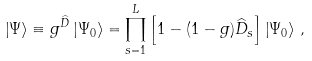<formula> <loc_0><loc_0><loc_500><loc_500>\left | \Psi \right \rangle \equiv g ^ { \widehat { D } } \left | \Psi _ { 0 } \right \rangle = \prod _ { s = 1 } ^ { L } \left [ 1 - ( 1 - g ) \widehat { D } _ { s } \right ] \left | \Psi _ { 0 } \right \rangle \, ,</formula> 